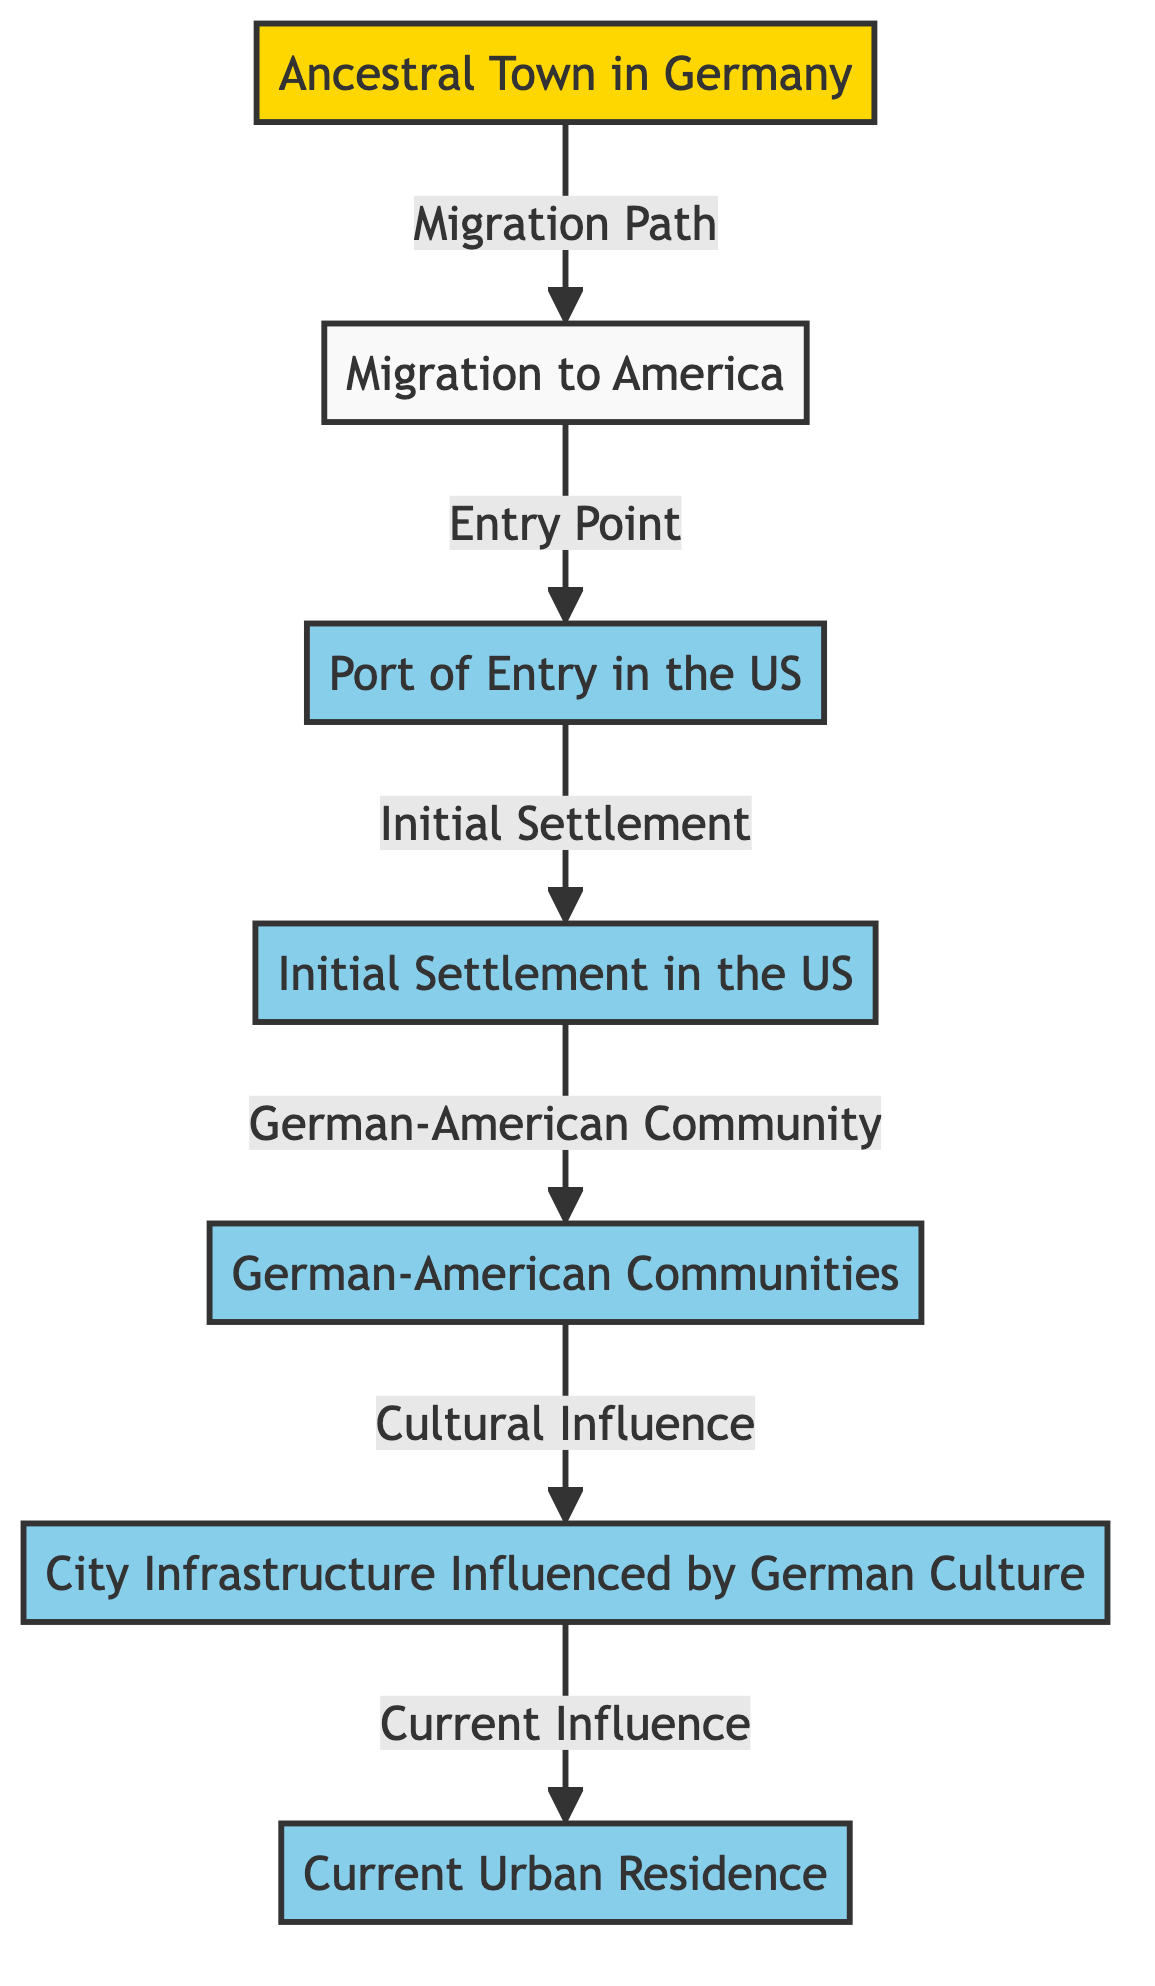What is the origin point for the family in Germany? The diagram specifies the "Ancestral Town in Germany" as the origin point. The label provided clearly indicates this node represents a town in Germany, such as Bremen.
Answer: Ancestral Town in Germany What is the first point of arrival in the United States? According to the diagram, the node labeled "Port of Entry in the US" indicates where the family first arrived in the United States. This important milestone in the migration path is represented specifically by Ellis Island in the example.
Answer: Port of Entry in the US How many nodes are in the diagram? By counting the listed nodes in the data, we find seven distinct nodes ranging from the ancestral town to the current urban residence. This total includes all major points in the migration and settlement process.
Answer: 7 What type of communities did the family establish in the US after initial settlement? The diagram describes the "German-American Communities" as regions where German immigrants, including the family, formed distinctive neighborhoods. In the context of the diagram, this refers to locations like German Village in Ohio.
Answer: German-American Communities What is the link label between "Initial Settlement in the US" and "German-American Communities"? The direct connection between these two nodes is indicated by the label "German-American Community." This label illustrates the relationship highlighting the establishment of a community following initial settlement.
Answer: German-American Community Which node represents the cultural influences of German heritage on city infrastructure? The diagram features a node labeled "City Infrastructure Influenced by German Culture," which encapsulates structures, landmarks, and community areas shaped by the German immigrant experience.
Answer: City Infrastructure Influenced by German Culture What is the relationship between "Migration to America" and "Port of Entry in the US"? The link between these two nodes is labeled "Entry Point," indicating that after migrating from Germany, there is a crucial step involving arriving at a port in the U.S.
Answer: Entry Point Which node is the final destination for the family's current residence? The last node in the sequence is designated as "Current Urban Residence," indicating where the family lives today in the context of their migration journey. This concludes the flow of information in the diagram.
Answer: Current Urban Residence What influences the current urban residence today? This influence is represented by the connection from the "City Infrastructure Influenced by German Culture" to the "Current Urban Residence," indicating how German heritage continues to shape present-day locations.
Answer: Current Influence 